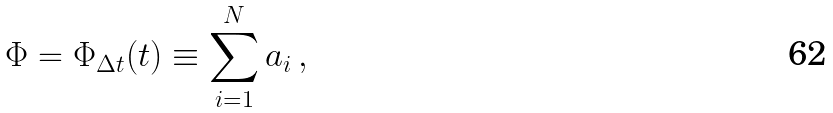<formula> <loc_0><loc_0><loc_500><loc_500>\Phi = \Phi _ { \Delta t } ( t ) \equiv \sum _ { i = 1 } ^ { N } a _ { i } \, ,</formula> 